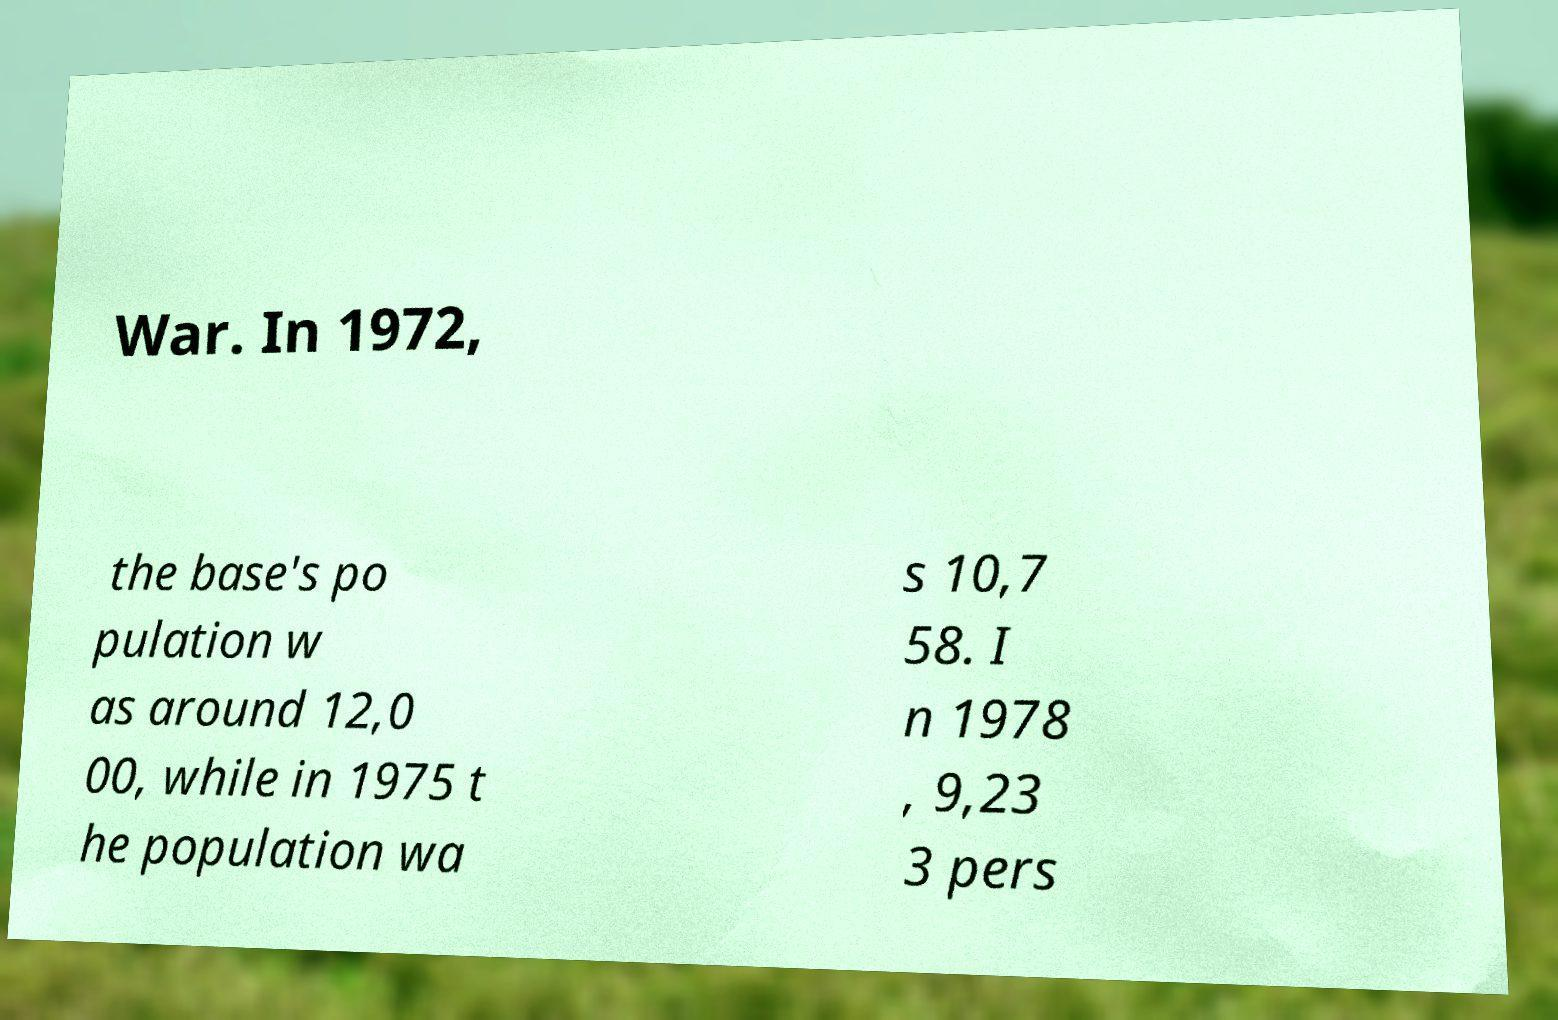Could you assist in decoding the text presented in this image and type it out clearly? War. In 1972, the base's po pulation w as around 12,0 00, while in 1975 t he population wa s 10,7 58. I n 1978 , 9,23 3 pers 